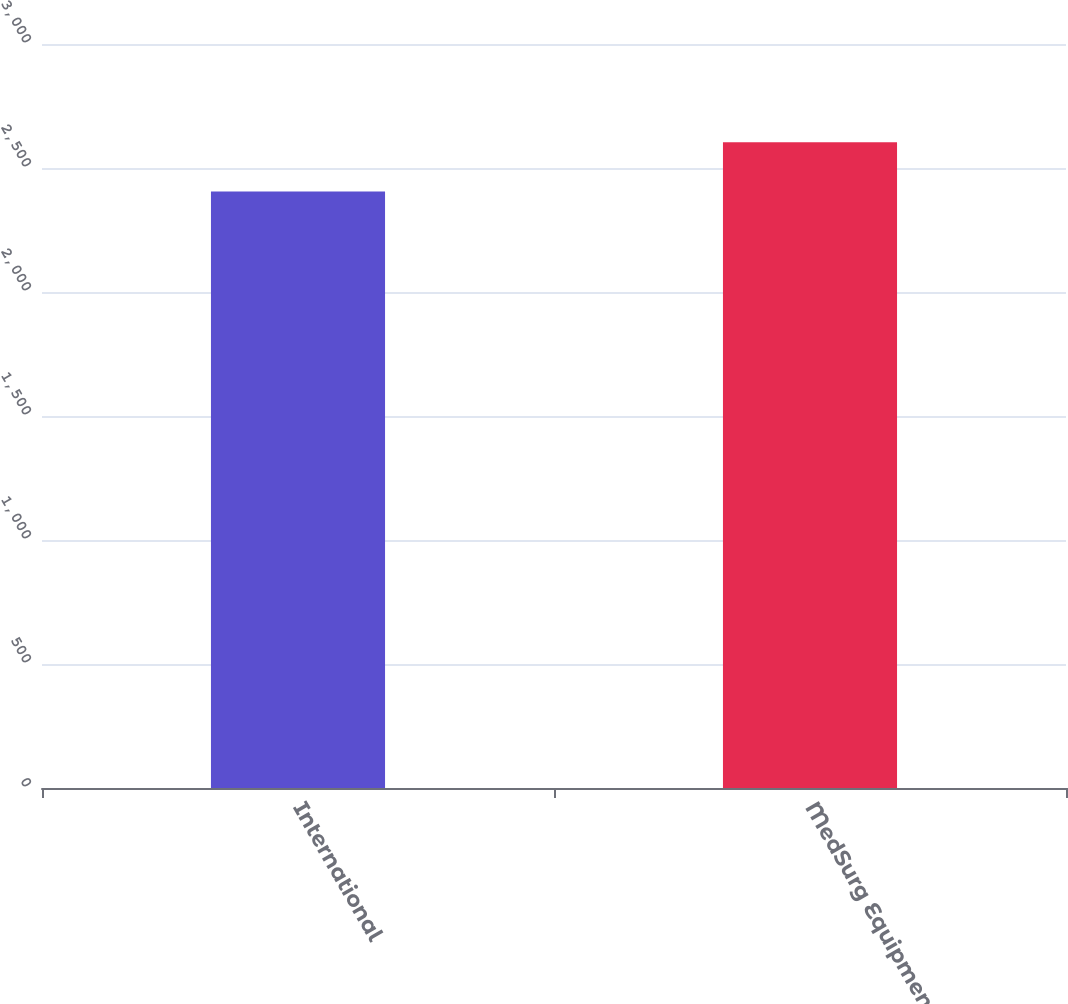<chart> <loc_0><loc_0><loc_500><loc_500><bar_chart><fcel>International<fcel>MedSurg Equipment<nl><fcel>2405.7<fcel>2603.4<nl></chart> 